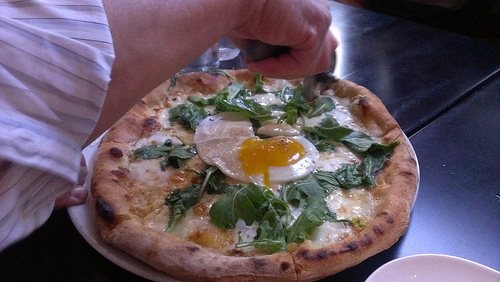How would this dish taste like? This dish likely has a delightful combination of flavors. The crust would be crunchy and slightly smoky from the char. The cheese, melted and gooey, adds a rich, creamy taste. The fresh spinach provides a light, slightly bitter contrast, and the egg, with its runny yolk, adds a savory richness that ties everything together. It’s a harmonious blend of textures and flavors that would be a treat to the taste buds. What other toppings would you suggest for this pizza? For additional toppings, you could consider adding some crispy bacon for a smoky, savory crunch. Sliced mushrooms would add an earthy depth, and perhaps a sprinkle of chili flakes for a hint of heat. A drizzle of truffle oil could elevate the dish with its luxurious aroma, and some shaved Parmesan cheese could finish it off with an extra layer of cheesy goodness. 